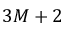<formula> <loc_0><loc_0><loc_500><loc_500>3 M + 2</formula> 